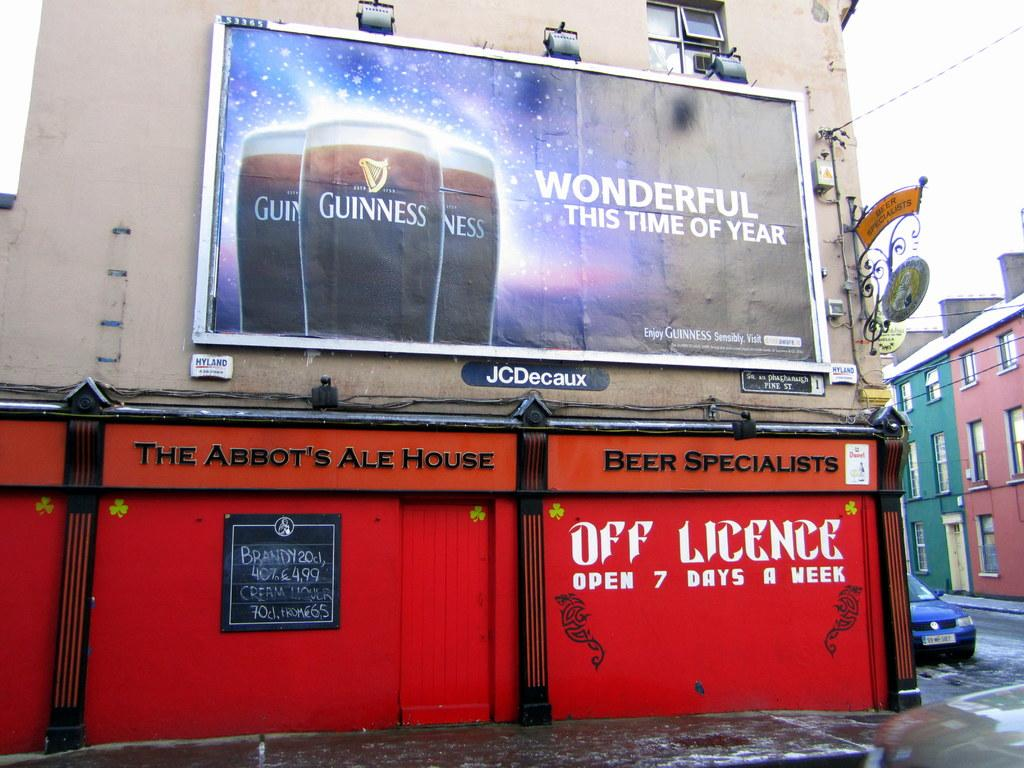<image>
Write a terse but informative summary of the picture. An ad for Guinness beer above The Abbot's Ale House. 